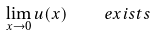<formula> <loc_0><loc_0><loc_500><loc_500>\lim _ { x \to 0 } u ( x ) \quad e x i s t s</formula> 